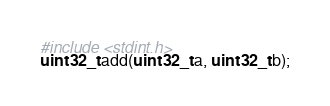Convert code to text. <code><loc_0><loc_0><loc_500><loc_500><_C_>#include <stdint.h>
uint32_t add(uint32_t a, uint32_t b);
</code> 